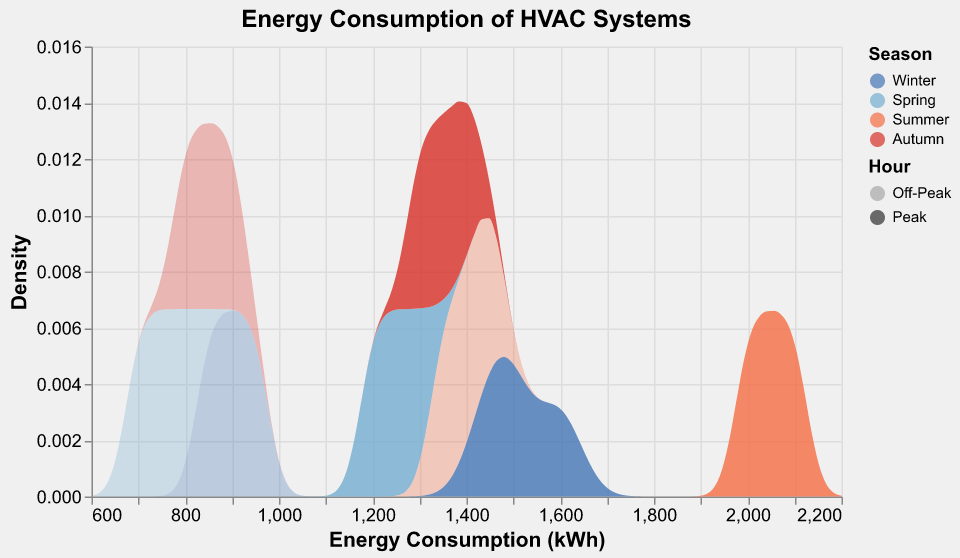What is the title of the plot? The title of the plot is positioned at the top and is typically the largest and boldest text. This title provides a clear description of the plot's content.
Answer: Energy Consumption of HVAC Systems Which season shows the highest peak energy consumption? Looking for the highest energy consumption value on the x-axis and finding the corresponding color and label in the legend. In this case, the peak energy consumption around 2100 kWh and the color is matched to Summer.
Answer: Summer What is the general trend in energy consumption between peak and off-peak hours? By comparing the density curves for peak and off-peak hours within each season, we can generally observe that peak hours have higher energy consumption. This is evident from the rightward shift of the peak curves compared to the off-peak curves.
Answer: Higher in peak hours Which season has the highest density of off-peak energy consumption around 850 kWh? By examining the density on the y-axis and looking for the season label where the curve peaks around 850 kWh on the x-axis, Autumn is identified with the highest density at this value, indicated by a peak in the curve.
Answer: Autumn How does peak energy consumption in Spring compare to peak energy consumption in Winter? Looking at the x-axis values for peak hours in both Spring and Winter, Winter's peak density curve is shifted more to the right (higher energy consumption) compared to Spring's curve.
Answer: Higher in Winter What is the approximate range of energy consumption values displayed on the x-axis? The x-axis marks the energy consumption range, with values extending from around 600 kWh to 2200 kWh.
Answer: 600 to 2200 kWh During which season and hour combination do we see the lowest energy consumption density values? The lowest energy consumption density values can typically be observed in the off-peak hours of Spring (~700 kWh and ~800 kWh), indicated by lower density peaks.
Answer: Off-peak in Spring Which season shows the most significant difference between peak and off-peak energy consumption densities? By looking at the separation and shift between the peak and off-peak density curves in each season, Summer shows the most significant difference with the widest range between the energy density peaks for peak and off-peak hours.
Answer: Summer What is the density of energy consumption in Winter peak at approximately 1500 kWh? Looking at the density curve for Winter's peak hours around the 1500 kWh mark on the x-axis, the associated y-axis value represents the density.
Answer: Approximately 0.006 